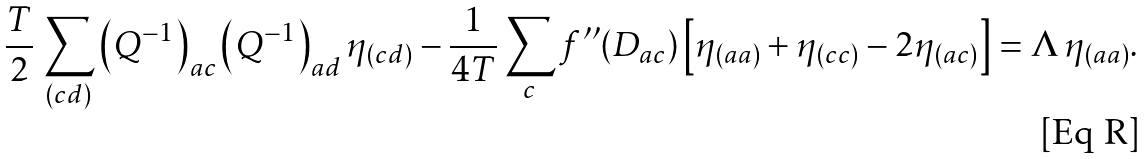Convert formula to latex. <formula><loc_0><loc_0><loc_500><loc_500>\frac { T } { 2 } \, \sum _ { ( c d ) } \left ( Q ^ { - 1 } \right ) _ { a c } \left ( Q ^ { - 1 } \right ) _ { a d } \eta _ { ( c d ) } - \frac { 1 } { 4 T } \sum _ { c } f ^ { \prime \prime } ( D _ { a c } ) \left [ \eta _ { ( a a ) } + \eta _ { ( c c ) } - 2 \eta _ { ( a c ) } \right ] = \Lambda \, \eta _ { ( a a ) } .</formula> 